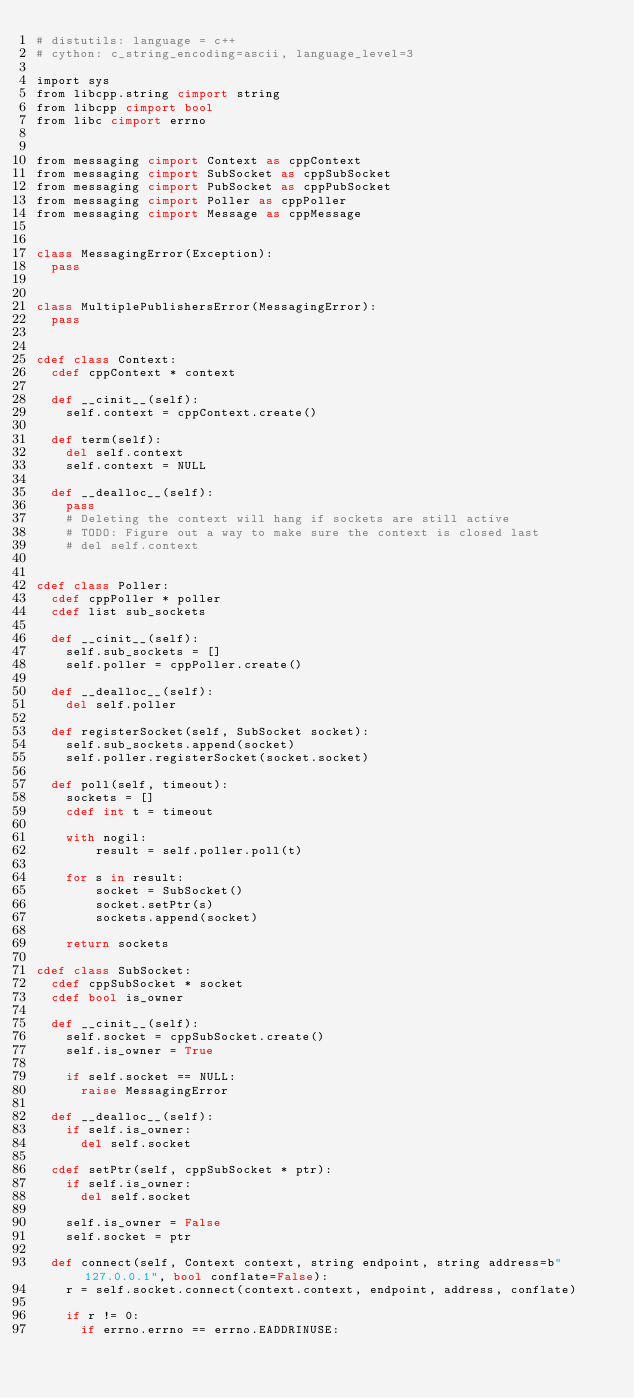Convert code to text. <code><loc_0><loc_0><loc_500><loc_500><_Cython_># distutils: language = c++
# cython: c_string_encoding=ascii, language_level=3

import sys
from libcpp.string cimport string
from libcpp cimport bool
from libc cimport errno


from messaging cimport Context as cppContext
from messaging cimport SubSocket as cppSubSocket
from messaging cimport PubSocket as cppPubSocket
from messaging cimport Poller as cppPoller
from messaging cimport Message as cppMessage


class MessagingError(Exception):
  pass


class MultiplePublishersError(MessagingError):
  pass


cdef class Context:
  cdef cppContext * context

  def __cinit__(self):
    self.context = cppContext.create()

  def term(self):
    del self.context
    self.context = NULL

  def __dealloc__(self):
    pass
    # Deleting the context will hang if sockets are still active
    # TODO: Figure out a way to make sure the context is closed last
    # del self.context


cdef class Poller:
  cdef cppPoller * poller
  cdef list sub_sockets

  def __cinit__(self):
    self.sub_sockets = []
    self.poller = cppPoller.create()

  def __dealloc__(self):
    del self.poller

  def registerSocket(self, SubSocket socket):
    self.sub_sockets.append(socket)
    self.poller.registerSocket(socket.socket)

  def poll(self, timeout):
    sockets = []
    cdef int t = timeout

    with nogil:
        result = self.poller.poll(t)

    for s in result:
        socket = SubSocket()
        socket.setPtr(s)
        sockets.append(socket)

    return sockets

cdef class SubSocket:
  cdef cppSubSocket * socket
  cdef bool is_owner

  def __cinit__(self):
    self.socket = cppSubSocket.create()
    self.is_owner = True

    if self.socket == NULL:
      raise MessagingError

  def __dealloc__(self):
    if self.is_owner:
      del self.socket

  cdef setPtr(self, cppSubSocket * ptr):
    if self.is_owner:
      del self.socket

    self.is_owner = False
    self.socket = ptr

  def connect(self, Context context, string endpoint, string address=b"127.0.0.1", bool conflate=False):
    r = self.socket.connect(context.context, endpoint, address, conflate)

    if r != 0:
      if errno.errno == errno.EADDRINUSE:</code> 